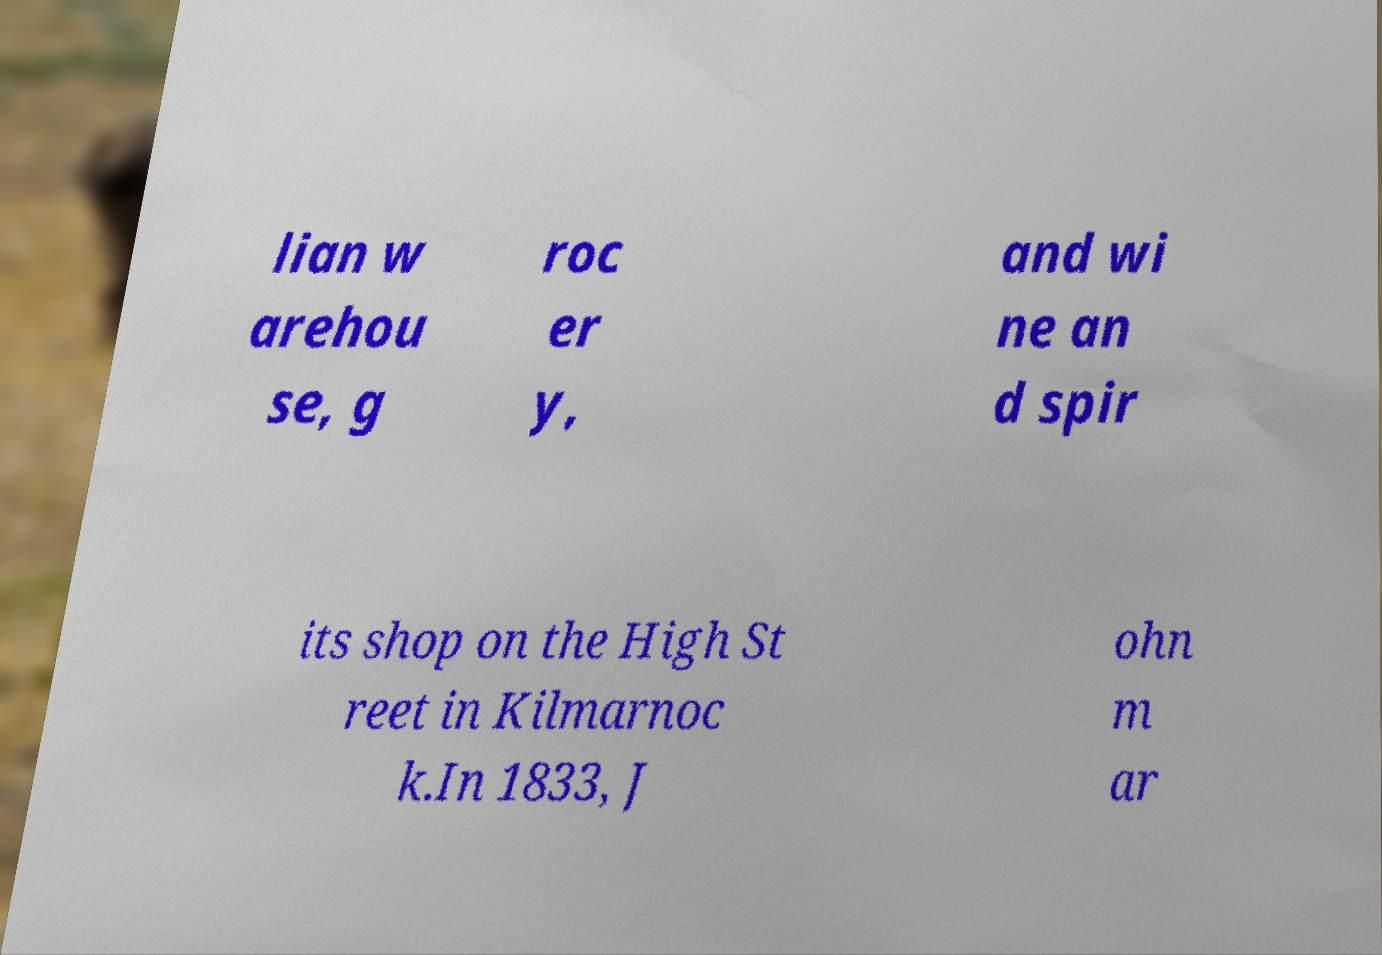What messages or text are displayed in this image? I need them in a readable, typed format. lian w arehou se, g roc er y, and wi ne an d spir its shop on the High St reet in Kilmarnoc k.In 1833, J ohn m ar 